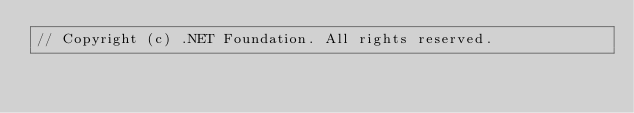Convert code to text. <code><loc_0><loc_0><loc_500><loc_500><_C#_>// Copyright (c) .NET Foundation. All rights reserved.</code> 